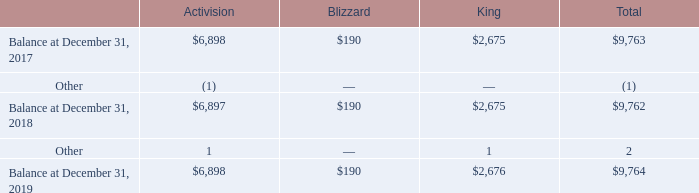8. Goodwill
The changes in the carrying amount of goodwill by operating segment are as follows (amounts in millions):
At December 31, 2019, 2018, and 2017, there were no accumulated impairment losses.
What was the balance in the carrying amount of goodwill by Blizzard in 2017?
Answer scale should be: million. $190. What was the balance in the carrying amount of goodwill by King in 2018?
Answer scale should be: million. $2,675. What was the balance in the carrying amount of goodwill by Activision in 2019?
Answer scale should be: million. $6,898. What was the difference in balance in 2017 between Activision and Blizzard?
Answer scale should be: million. $6,898-$190
Answer: 6708. What was the difference in balance in 2019 between Activision and King?
Answer scale should be: million. $6,898-$2,676
Answer: 4222. What is the percentage of total balance in 2018 that consists of balance by King?
Answer scale should be: percent. $2,675/$9,762
Answer: 27.4. 